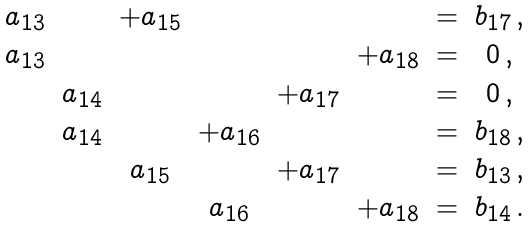Convert formula to latex. <formula><loc_0><loc_0><loc_500><loc_500>\begin{matrix} a _ { 1 3 } & & + a _ { 1 5 } & & & & = & b _ { 1 7 } \, , \\ a _ { 1 3 } & & & & & + a _ { 1 8 } & = & 0 \, , \\ & a _ { 1 4 } & & & + a _ { 1 7 } & & = & 0 \, , \\ & a _ { 1 4 } & & + a _ { 1 6 } & & & = & b _ { 1 8 } \, , \\ & & a _ { 1 5 } & & + a _ { 1 7 } & & = & b _ { 1 3 } \, , \\ & & & a _ { 1 6 } & & + a _ { 1 8 } & = & b _ { 1 4 } \, . \end{matrix}</formula> 